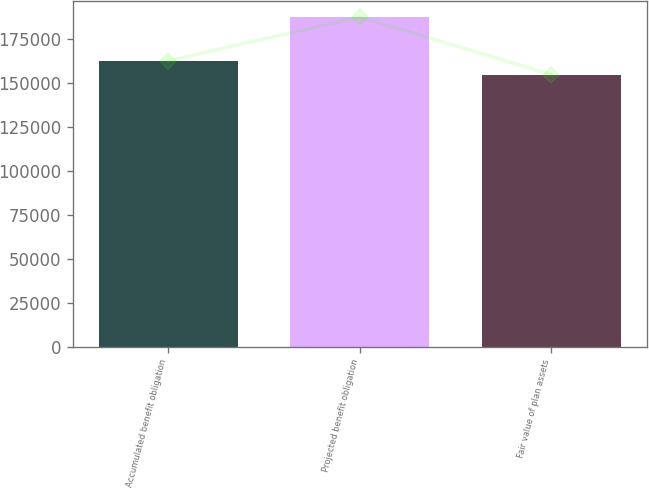<chart> <loc_0><loc_0><loc_500><loc_500><bar_chart><fcel>Accumulated benefit obligation<fcel>Projected benefit obligation<fcel>Fair value of plan assets<nl><fcel>162595<fcel>187493<fcel>154754<nl></chart> 